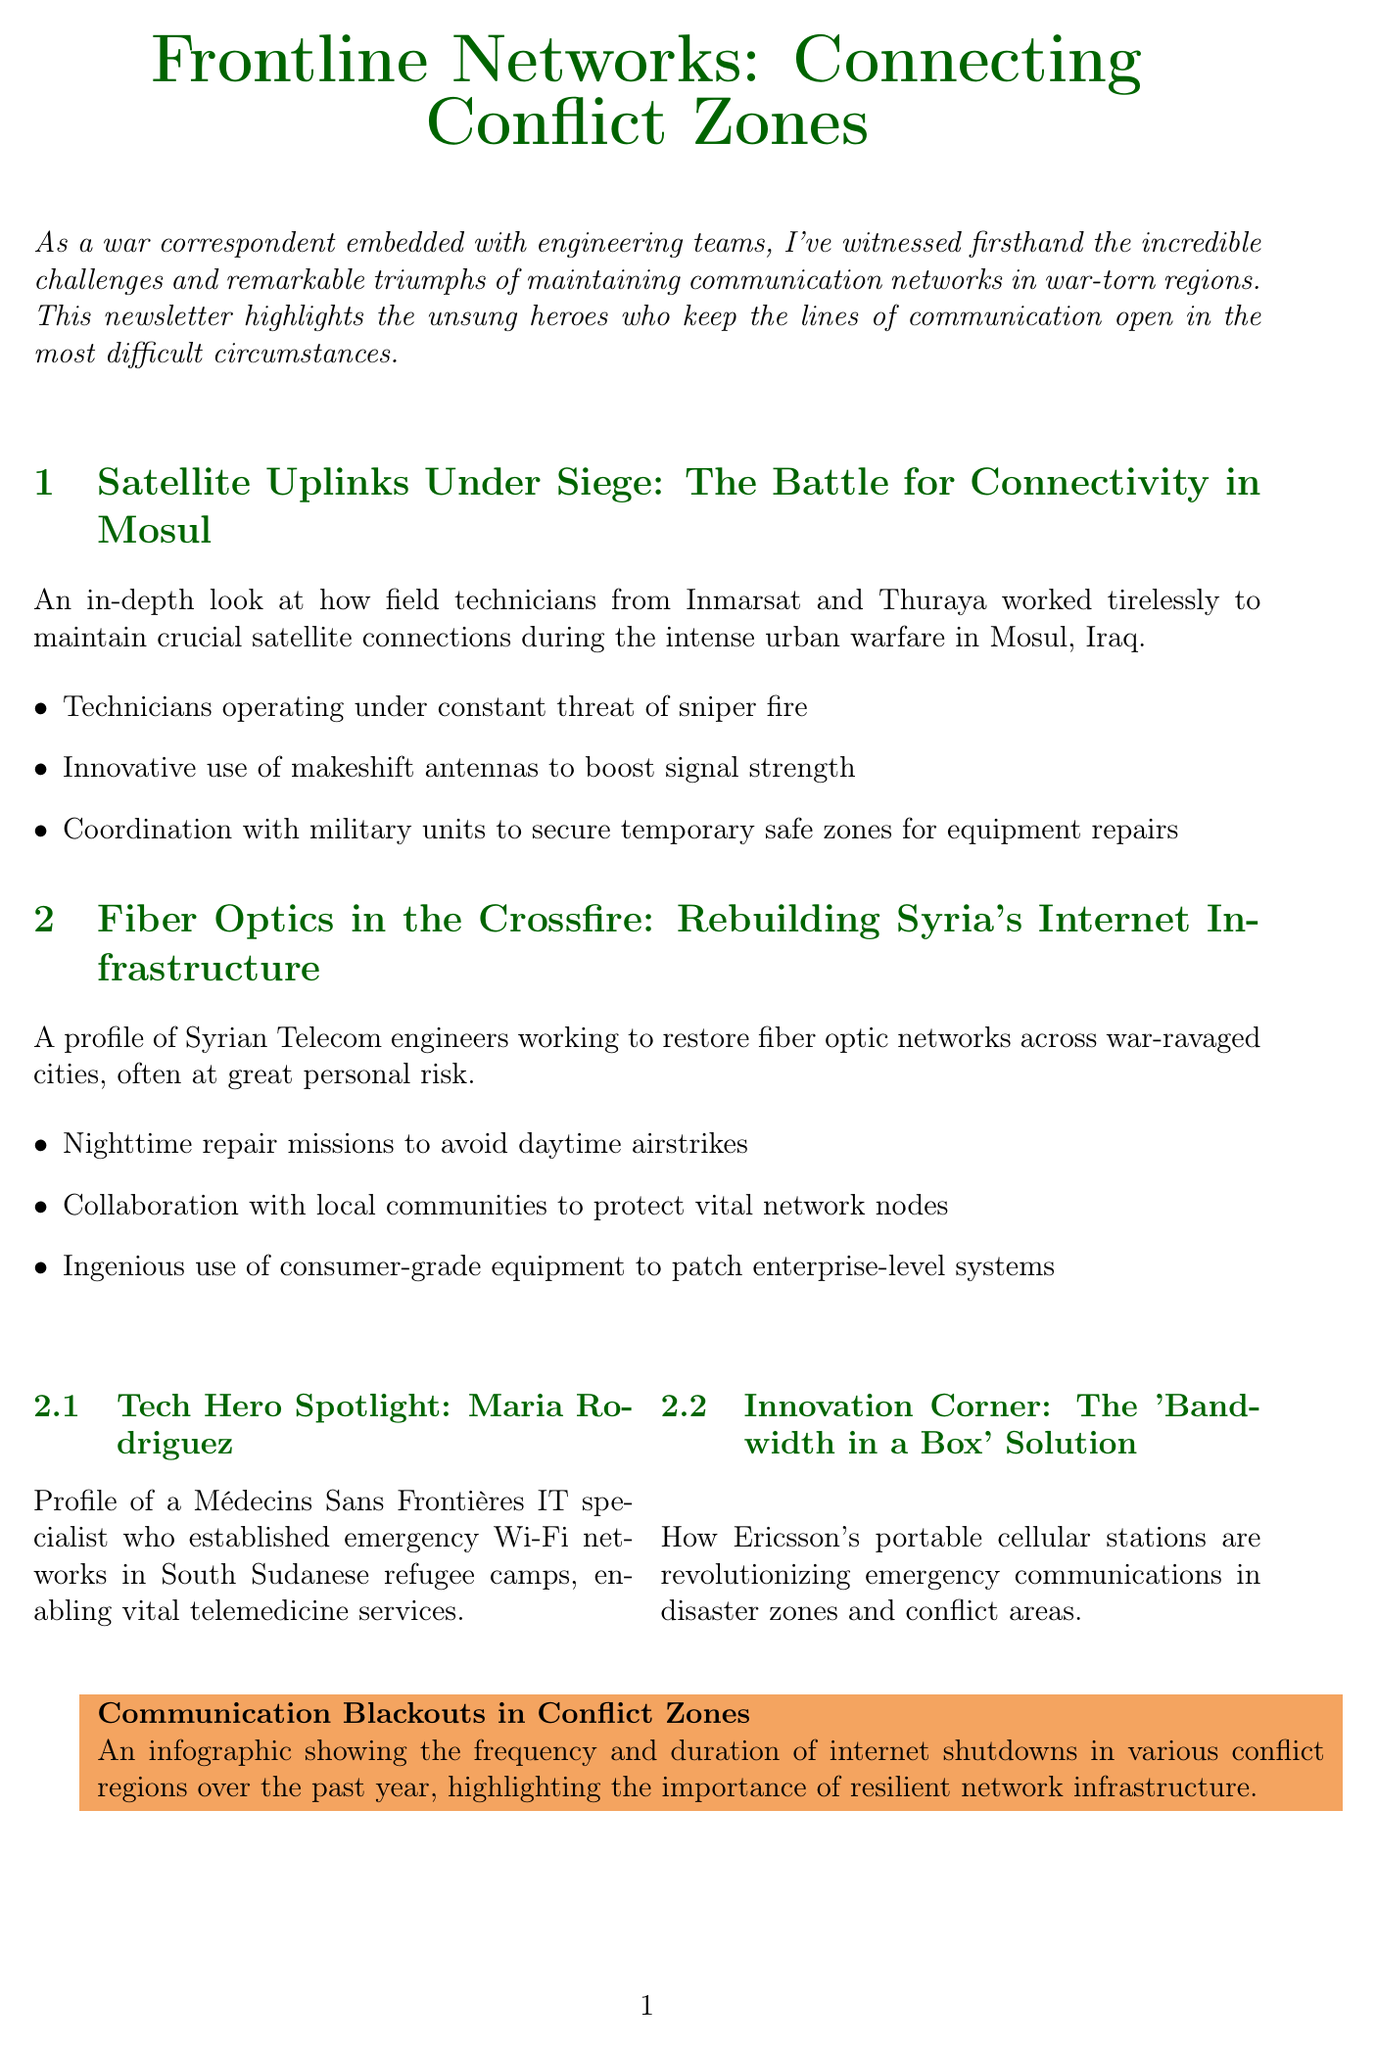What is the title of the newsletter? The title of the newsletter is presented prominently at the beginning of the document.
Answer: Frontline Networks: Connecting Conflict Zones Who established emergency Wi-Fi networks in South Sudanese refugee camps? This information is found in the "Tech Hero Spotlight" section, which describes a specific individual's contribution.
Answer: Maria Rodriguez How many articles are included in the main section of the newsletter? The number of articles can be determined by counting the sections under "mainArticles" in the document.
Answer: 2 What was the focus of the article "Fiber Optics in the Crossfire"? The title of the article indicates its main focus, and the summary provides additional context.
Answer: Restoring fiber optic networks What innovative solution is mentioned in the "Innovation Corner"? The description of the "Innovation Corner" section provides details about a specific technology.
Answer: Bandwidth in a Box What type of infographic is included in the document? The "dataVisualization" section describes the content and purpose of the infographic.
Answer: Communication Blackouts in Conflict Zones During which time are Syrian Telecom engineers conducting repair missions? The key point under the "Fiber Optics in the Crossfire" article gives this information.
Answer: Nighttime Who is the interviewee in the military perspective section? The interview segment clearly mentions the name of the individual being interviewed.
Answer: Colonel John Bradshaw What significant challenges do technicians face in Mosul? The key points listed under the relevant article highlight the main challenges experienced by technicians.
Answer: Sniper fire 